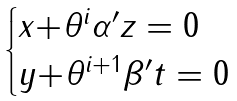<formula> <loc_0><loc_0><loc_500><loc_500>\begin{cases} x { + } \theta ^ { i } \alpha ^ { \prime } z = 0 \\ y { + } \theta ^ { i { + } 1 } \beta ^ { \prime } t = 0 \end{cases}</formula> 